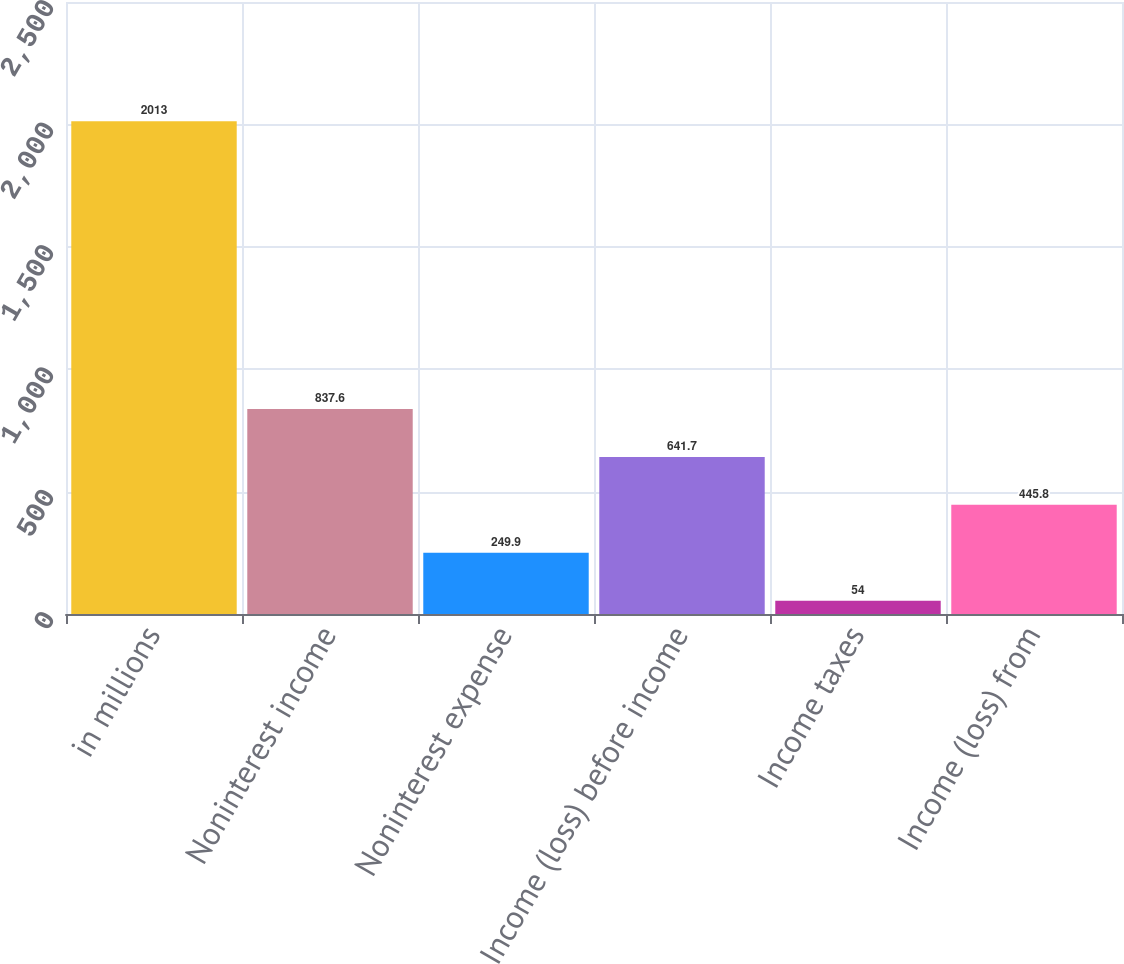Convert chart to OTSL. <chart><loc_0><loc_0><loc_500><loc_500><bar_chart><fcel>in millions<fcel>Noninterest income<fcel>Noninterest expense<fcel>Income (loss) before income<fcel>Income taxes<fcel>Income (loss) from<nl><fcel>2013<fcel>837.6<fcel>249.9<fcel>641.7<fcel>54<fcel>445.8<nl></chart> 